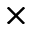Convert formula to latex. <formula><loc_0><loc_0><loc_500><loc_500>\times</formula> 